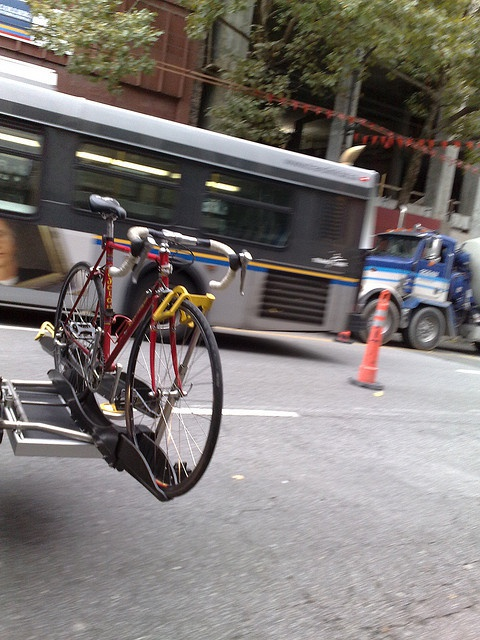Describe the objects in this image and their specific colors. I can see bus in gray, black, lightgray, and darkgray tones, bicycle in gray, black, darkgray, and lightgray tones, and truck in gray, black, darkgray, and lightgray tones in this image. 